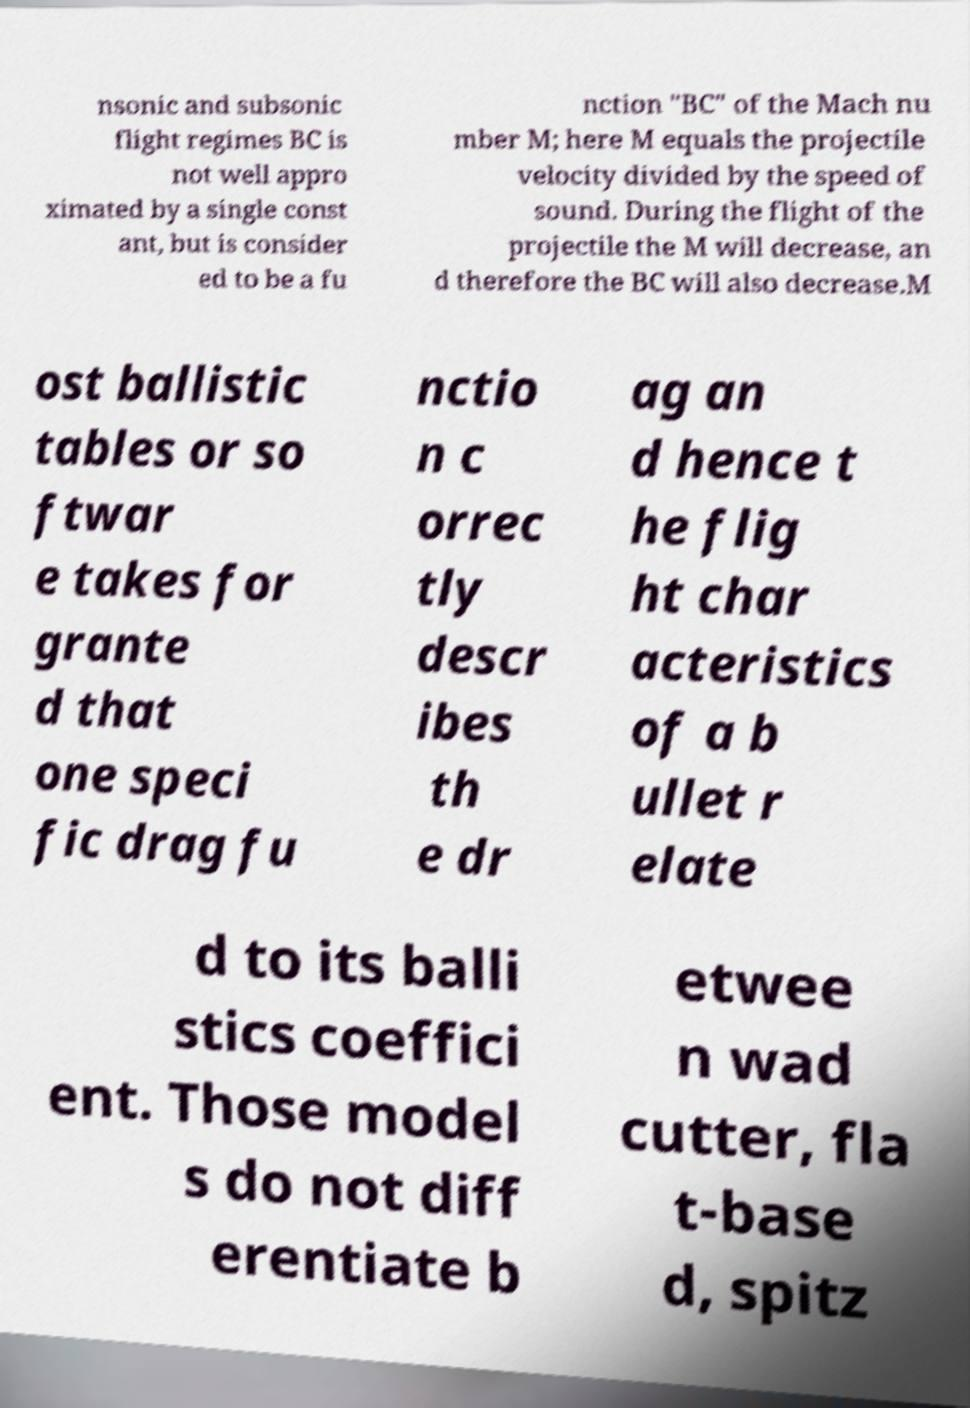Please identify and transcribe the text found in this image. nsonic and subsonic flight regimes BC is not well appro ximated by a single const ant, but is consider ed to be a fu nction "BC" of the Mach nu mber M; here M equals the projectile velocity divided by the speed of sound. During the flight of the projectile the M will decrease, an d therefore the BC will also decrease.M ost ballistic tables or so ftwar e takes for grante d that one speci fic drag fu nctio n c orrec tly descr ibes th e dr ag an d hence t he flig ht char acteristics of a b ullet r elate d to its balli stics coeffici ent. Those model s do not diff erentiate b etwee n wad cutter, fla t-base d, spitz 